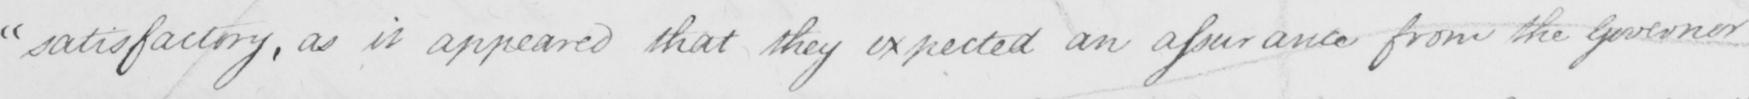What is written in this line of handwriting? " satisfactory , as it appeared that they expected an assurance from the governor 